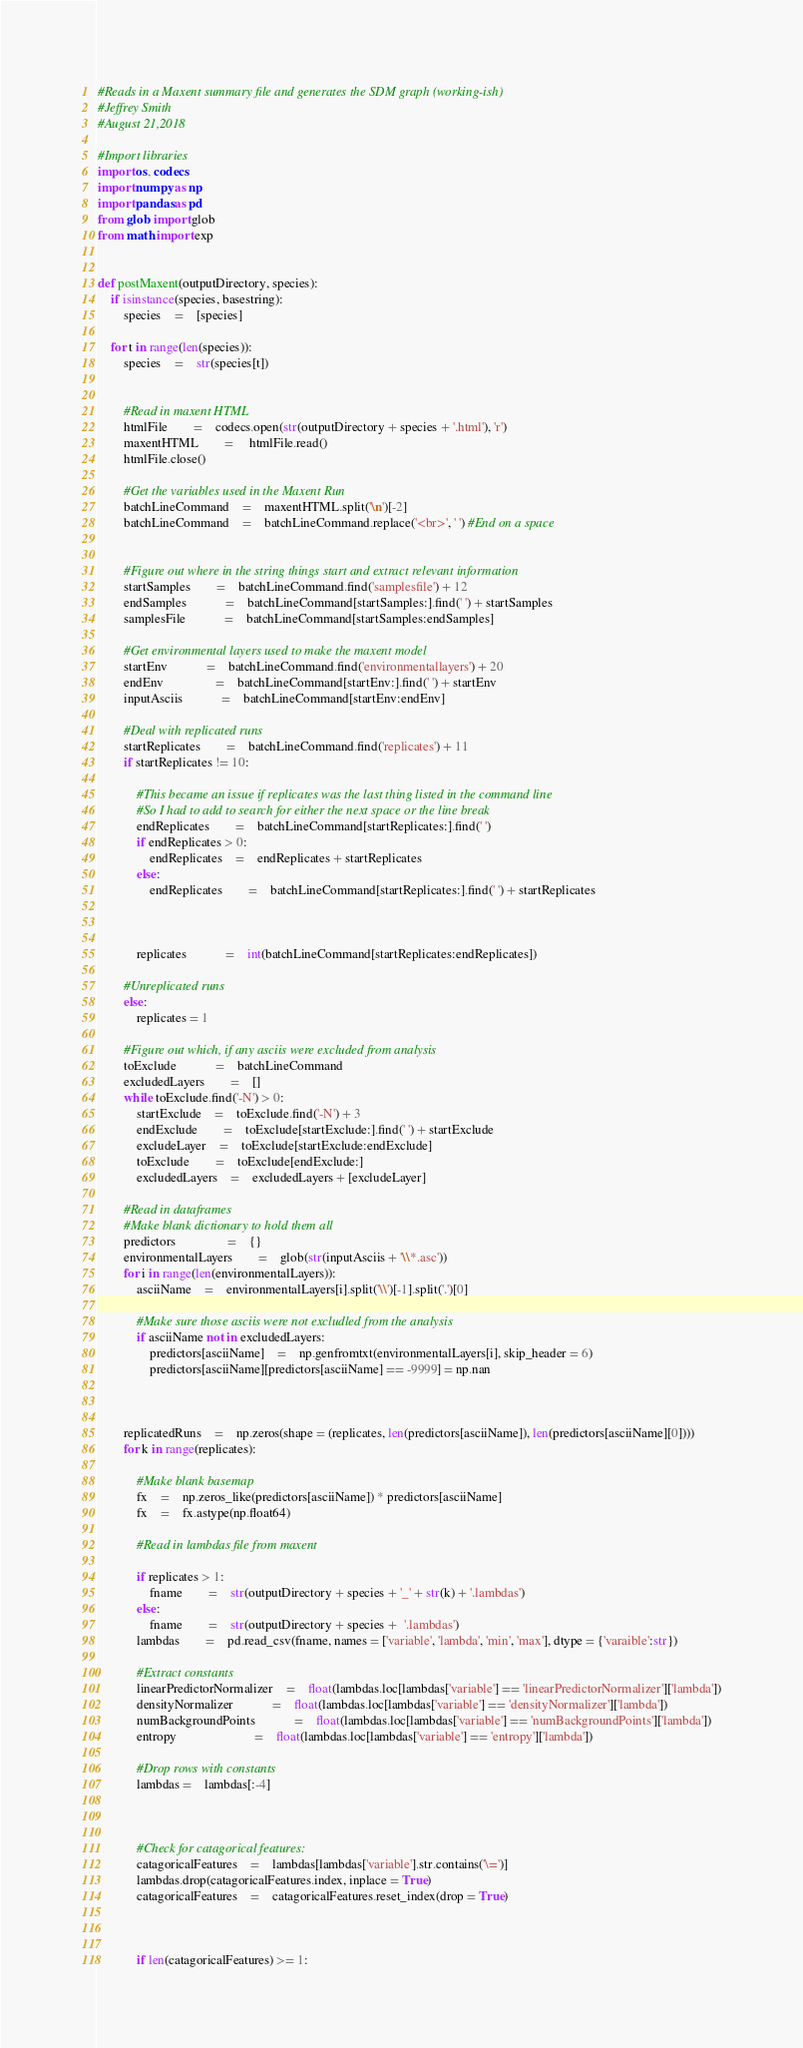<code> <loc_0><loc_0><loc_500><loc_500><_Python_>#Reads in a Maxent summary file and generates the SDM graph (working-ish)
#Jeffrey Smith
#August 21,2018

#Import libraries
import os, codecs
import numpy as np
import pandas as pd
from glob import glob
from math import exp


def postMaxent(outputDirectory, species):
	if isinstance(species, basestring):
		species	=	[species]
	
	for t in range(len(species)):
		species	=	str(species[t])


		#Read in maxent HTML
		htmlFile		=	codecs.open(str(outputDirectory + species + '.html'), 'r')
		maxentHTML		=	 htmlFile.read()
		htmlFile.close()

		#Get the variables used in the Maxent Run
		batchLineCommand	=	maxentHTML.split('\n')[-2]
		batchLineCommand	=	batchLineCommand.replace('<br>', ' ') #End on a space


		#Figure out where in the string things start and extract relevant information
		startSamples 		=	batchLineCommand.find('samplesfile') + 12
		endSamples			=	batchLineCommand[startSamples:].find(' ') + startSamples
		samplesFile			=	batchLineCommand[startSamples:endSamples]

		#Get environmental layers used to make the maxent model
		startEnv			=	batchLineCommand.find('environmentallayers') + 20 
		endEnv				=	batchLineCommand[startEnv:].find(' ') + startEnv
		inputAsciis			=	batchLineCommand[startEnv:endEnv]

		#Deal with replicated runs
		startReplicates		=	batchLineCommand.find('replicates') + 11 
		if startReplicates != 10:
		
			#This became an issue if replicates was the last thing listed in the command line
			#So I had to add to search for either the next space or the line break
			endReplicates		=	batchLineCommand[startReplicates:].find(' ')
			if endReplicates > 0:
				endReplicates	=	endReplicates + startReplicates
			else:
				endReplicates		=	batchLineCommand[startReplicates:].find(' ') + startReplicates


			
			replicates			=	int(batchLineCommand[startReplicates:endReplicates])
		
		#Unreplicated runs
		else:
			replicates = 1

		#Figure out which, if any asciis were excluded from analysis
		toExclude			=	batchLineCommand
		excludedLayers		=	[]
		while toExclude.find('-N') > 0:
			startExclude	=	toExclude.find('-N') + 3 
			endExclude		=	toExclude[startExclude:].find(' ') + startExclude
			excludeLayer	=	toExclude[startExclude:endExclude]
			toExclude		=	toExclude[endExclude:]
			excludedLayers	=	excludedLayers + [excludeLayer]

		#Read in dataframes	
		#Make blank dictionary to hold them all
		predictors				=	{}
		environmentalLayers		=	glob(str(inputAsciis + '\\*.asc'))
		for i in range(len(environmentalLayers)):
			asciiName	=	environmentalLayers[i].split('\\')[-1].split('.')[0]
			
			#Make sure those asciis were not excludled from the analysis
			if asciiName not in excludedLayers:
				predictors[asciiName]	=	np.genfromtxt(environmentalLayers[i], skip_header = 6)
				predictors[asciiName][predictors[asciiName] == -9999] = np.nan

				

		replicatedRuns	=	np.zeros(shape = (replicates, len(predictors[asciiName]), len(predictors[asciiName][0])))
		for k in range(replicates):
					
			#Make blank basemap
			fx	=	np.zeros_like(predictors[asciiName]) * predictors[asciiName]
			fx	=	fx.astype(np.float64)
					
			#Read in lambdas file from maxent
			
			if replicates > 1:
				fname		=	str(outputDirectory + species + '_' + str(k) + '.lambdas')
			else:
				fname		=	str(outputDirectory + species +  '.lambdas')
			lambdas		=	pd.read_csv(fname, names = ['variable', 'lambda', 'min', 'max'], dtype = {'varaible':str})		
			
			#Extract constants
			linearPredictorNormalizer	=	float(lambdas.loc[lambdas['variable'] == 'linearPredictorNormalizer']['lambda'])
			densityNormalizer			=	float(lambdas.loc[lambdas['variable'] == 'densityNormalizer']['lambda'])
			numBackgroundPoints			=	float(lambdas.loc[lambdas['variable'] == 'numBackgroundPoints']['lambda'])
			entropy						=	float(lambdas.loc[lambdas['variable'] == 'entropy']['lambda'])

			#Drop rows with constants
			lambdas = 	lambdas[:-4]
		
		
		
			#Check for catagorical features:
			catagoricalFeatures	=	lambdas[lambdas['variable'].str.contains('\=')]
			lambdas.drop(catagoricalFeatures.index, inplace = True)
			catagoricalFeatures	=	catagoricalFeatures.reset_index(drop = True)
			
			

			if len(catagoricalFeatures) >= 1:</code> 